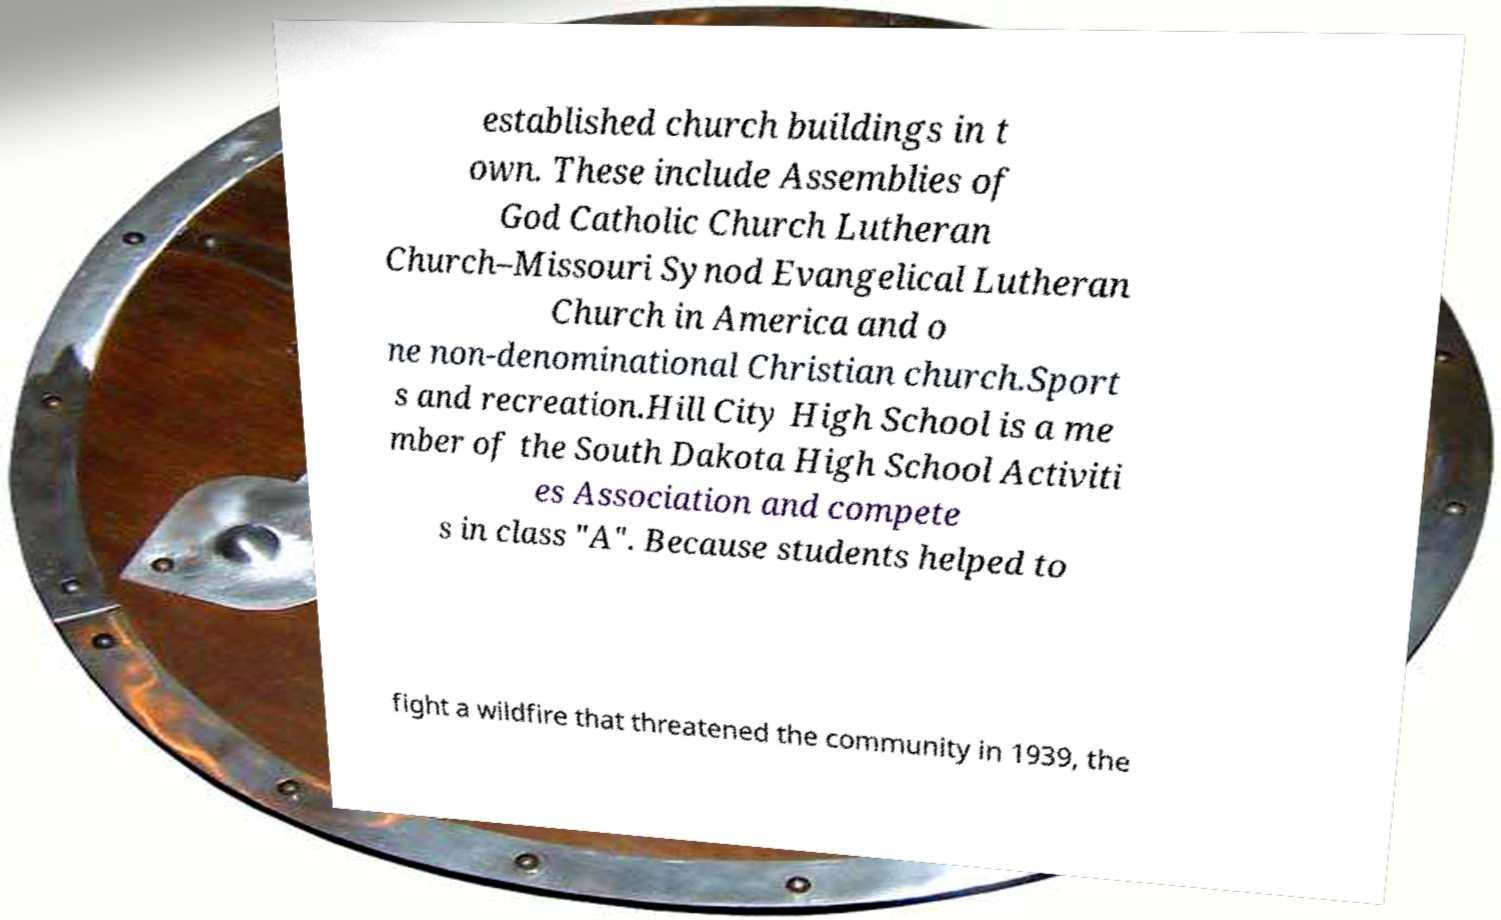Can you read and provide the text displayed in the image?This photo seems to have some interesting text. Can you extract and type it out for me? established church buildings in t own. These include Assemblies of God Catholic Church Lutheran Church–Missouri Synod Evangelical Lutheran Church in America and o ne non-denominational Christian church.Sport s and recreation.Hill City High School is a me mber of the South Dakota High School Activiti es Association and compete s in class "A". Because students helped to fight a wildfire that threatened the community in 1939, the 